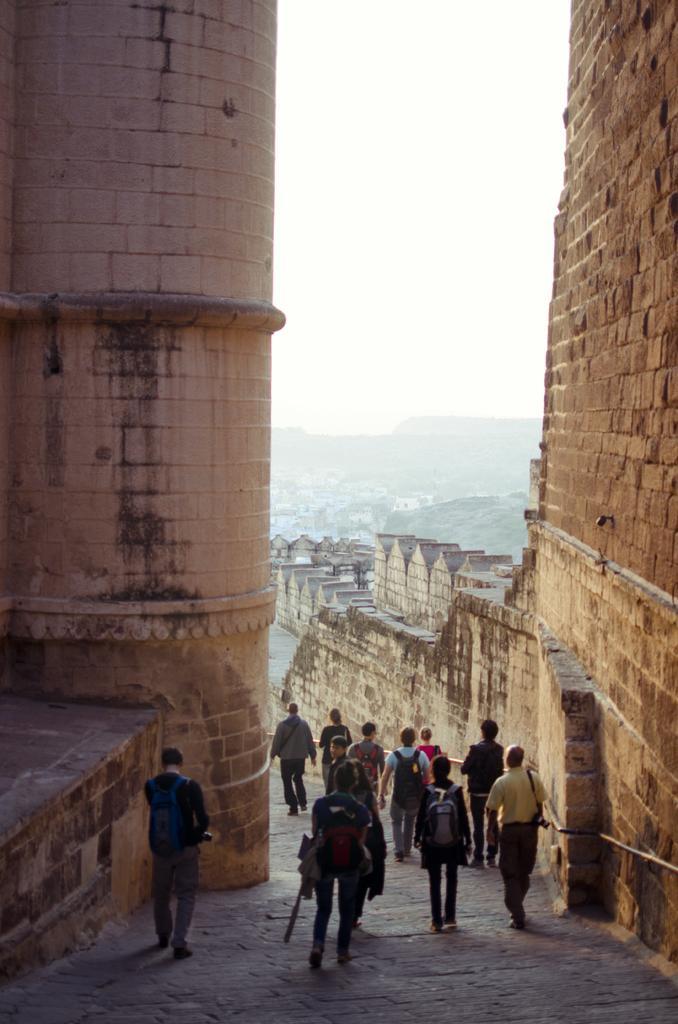Describe this image in one or two sentences. In this image we can see a group of people walking on the pathway. We can also see a monument. On the backside we can see some buildings, the hills and the sky which looks cloudy. 